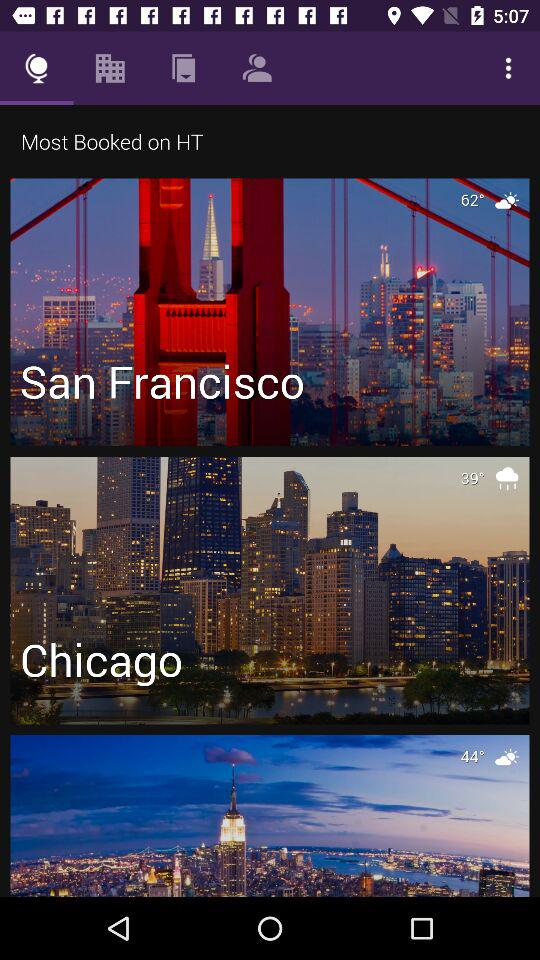What is the temperature in San Francisco? The temperature is 62 degrees. 